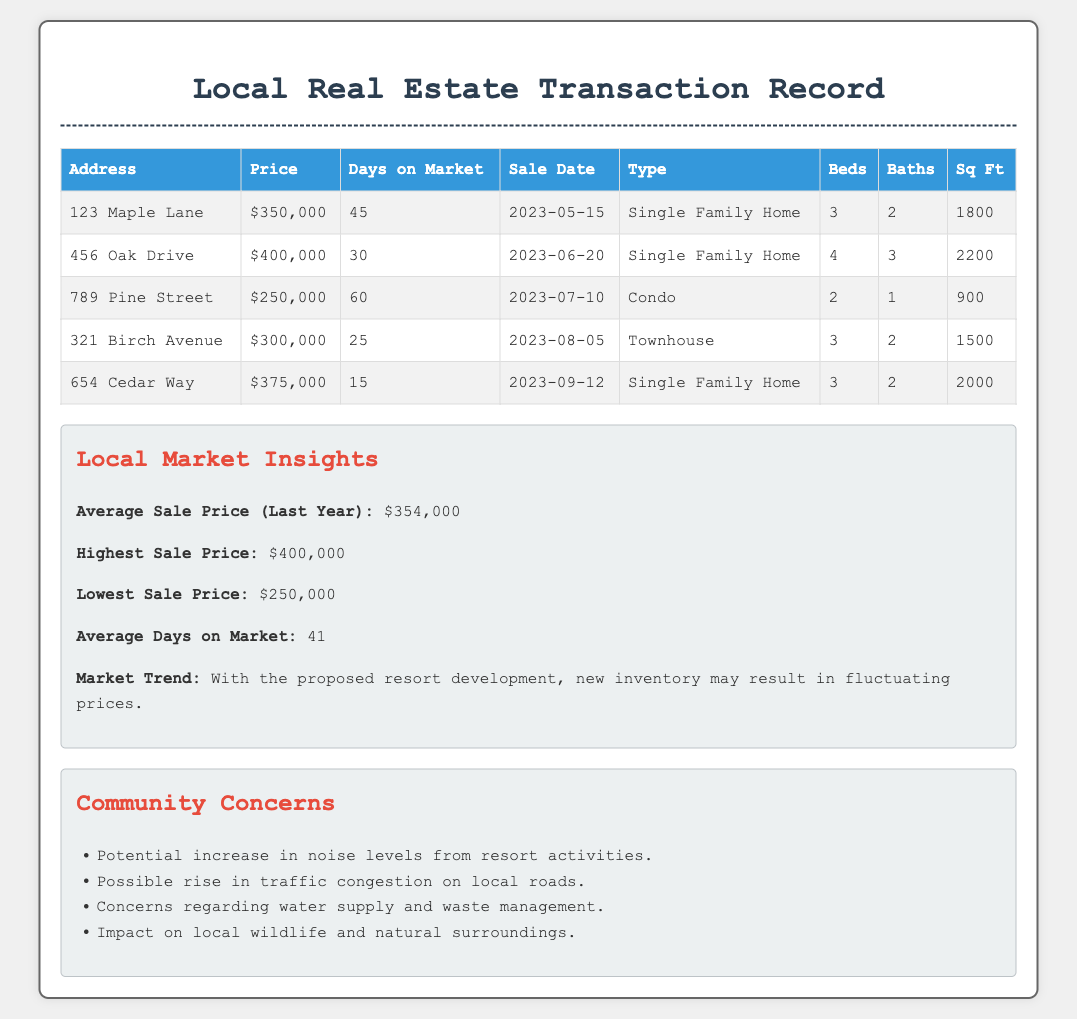What is the highest sale price? The highest sale price listed in the document is $400,000.
Answer: $400,000 How many days was the property at 321 Birch Avenue on the market? The document states that the property at 321 Birch Avenue was on the market for 25 days.
Answer: 25 What type of property is 789 Pine Street? The document categorizes the property at 789 Pine Street as a Condo.
Answer: Condo What is the average sale price in the last year? The document indicates that the average sale price in the last year is $354,000.
Answer: $354,000 How many bedrooms does the property at 654 Cedar Way have? The document specifies that the property at 654 Cedar Way has 3 bedrooms.
Answer: 3 What is the average number of days on market for the properties listed? The document mentions that the average number of days on market is 41.
Answer: 41 What property type has the lowest sale price in the document? The document shows that the Condo has the lowest sale price at $250,000.
Answer: Condo What major community concern is mentioned related to the proposed resort? The document cites the potential increase in noise levels as a major community concern.
Answer: Noise levels 